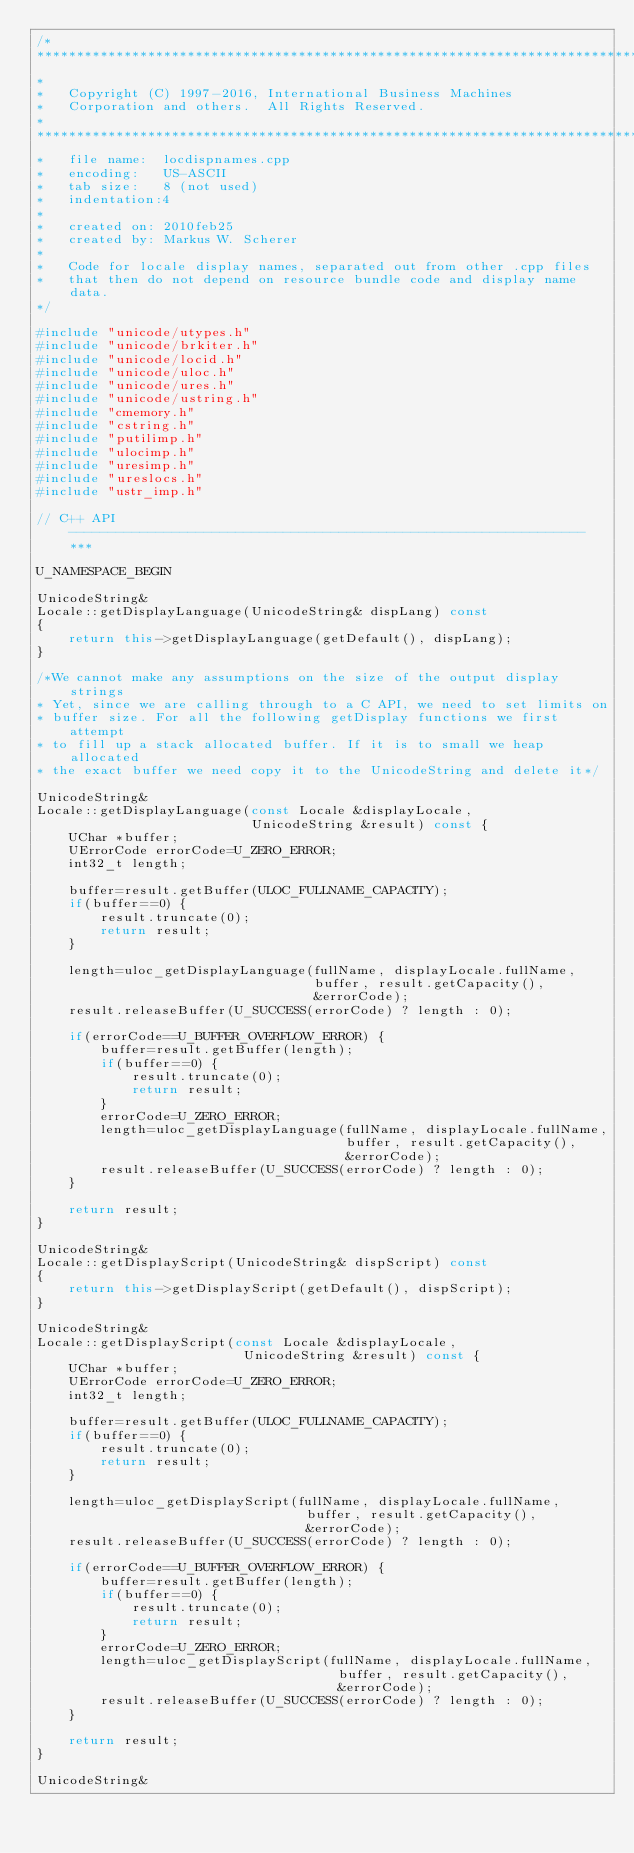<code> <loc_0><loc_0><loc_500><loc_500><_C++_>/*
*******************************************************************************
*
*   Copyright (C) 1997-2016, International Business Machines
*   Corporation and others.  All Rights Reserved.
*
*******************************************************************************
*   file name:  locdispnames.cpp
*   encoding:   US-ASCII
*   tab size:   8 (not used)
*   indentation:4
*
*   created on: 2010feb25
*   created by: Markus W. Scherer
*
*   Code for locale display names, separated out from other .cpp files
*   that then do not depend on resource bundle code and display name data.
*/

#include "unicode/utypes.h"
#include "unicode/brkiter.h"
#include "unicode/locid.h"
#include "unicode/uloc.h"
#include "unicode/ures.h"
#include "unicode/ustring.h"
#include "cmemory.h"
#include "cstring.h"
#include "putilimp.h"
#include "ulocimp.h"
#include "uresimp.h"
#include "ureslocs.h"
#include "ustr_imp.h"

// C++ API ----------------------------------------------------------------- ***

U_NAMESPACE_BEGIN

UnicodeString&
Locale::getDisplayLanguage(UnicodeString& dispLang) const
{
    return this->getDisplayLanguage(getDefault(), dispLang);
}

/*We cannot make any assumptions on the size of the output display strings
* Yet, since we are calling through to a C API, we need to set limits on
* buffer size. For all the following getDisplay functions we first attempt
* to fill up a stack allocated buffer. If it is to small we heap allocated
* the exact buffer we need copy it to the UnicodeString and delete it*/

UnicodeString&
Locale::getDisplayLanguage(const Locale &displayLocale,
                           UnicodeString &result) const {
    UChar *buffer;
    UErrorCode errorCode=U_ZERO_ERROR;
    int32_t length;

    buffer=result.getBuffer(ULOC_FULLNAME_CAPACITY);
    if(buffer==0) {
        result.truncate(0);
        return result;
    }

    length=uloc_getDisplayLanguage(fullName, displayLocale.fullName,
                                   buffer, result.getCapacity(),
                                   &errorCode);
    result.releaseBuffer(U_SUCCESS(errorCode) ? length : 0);

    if(errorCode==U_BUFFER_OVERFLOW_ERROR) {
        buffer=result.getBuffer(length);
        if(buffer==0) {
            result.truncate(0);
            return result;
        }
        errorCode=U_ZERO_ERROR;
        length=uloc_getDisplayLanguage(fullName, displayLocale.fullName,
                                       buffer, result.getCapacity(),
                                       &errorCode);
        result.releaseBuffer(U_SUCCESS(errorCode) ? length : 0);
    }

    return result;
}

UnicodeString&
Locale::getDisplayScript(UnicodeString& dispScript) const
{
    return this->getDisplayScript(getDefault(), dispScript);
}

UnicodeString&
Locale::getDisplayScript(const Locale &displayLocale,
                          UnicodeString &result) const {
    UChar *buffer;
    UErrorCode errorCode=U_ZERO_ERROR;
    int32_t length;

    buffer=result.getBuffer(ULOC_FULLNAME_CAPACITY);
    if(buffer==0) {
        result.truncate(0);
        return result;
    }

    length=uloc_getDisplayScript(fullName, displayLocale.fullName,
                                  buffer, result.getCapacity(),
                                  &errorCode);
    result.releaseBuffer(U_SUCCESS(errorCode) ? length : 0);

    if(errorCode==U_BUFFER_OVERFLOW_ERROR) {
        buffer=result.getBuffer(length);
        if(buffer==0) {
            result.truncate(0);
            return result;
        }
        errorCode=U_ZERO_ERROR;
        length=uloc_getDisplayScript(fullName, displayLocale.fullName,
                                      buffer, result.getCapacity(),
                                      &errorCode);
        result.releaseBuffer(U_SUCCESS(errorCode) ? length : 0);
    }

    return result;
}

UnicodeString&</code> 